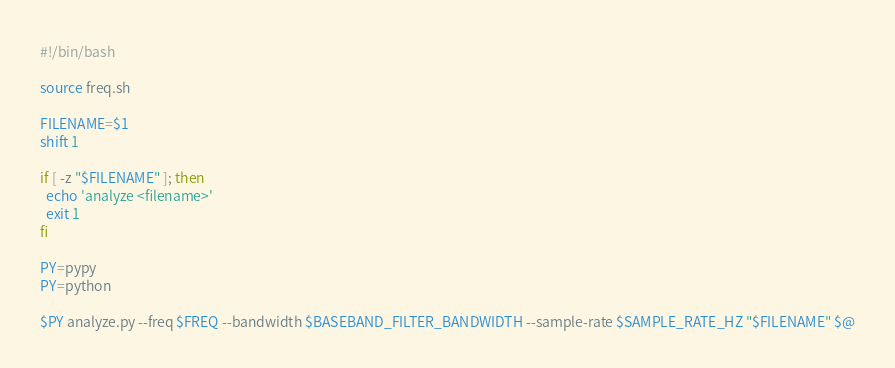Convert code to text. <code><loc_0><loc_0><loc_500><loc_500><_Bash_>#!/bin/bash

source freq.sh

FILENAME=$1
shift 1

if [ -z "$FILENAME" ]; then
  echo 'analyze <filename>'
  exit 1
fi

PY=pypy
PY=python

$PY analyze.py --freq $FREQ --bandwidth $BASEBAND_FILTER_BANDWIDTH --sample-rate $SAMPLE_RATE_HZ "$FILENAME" $@

</code> 